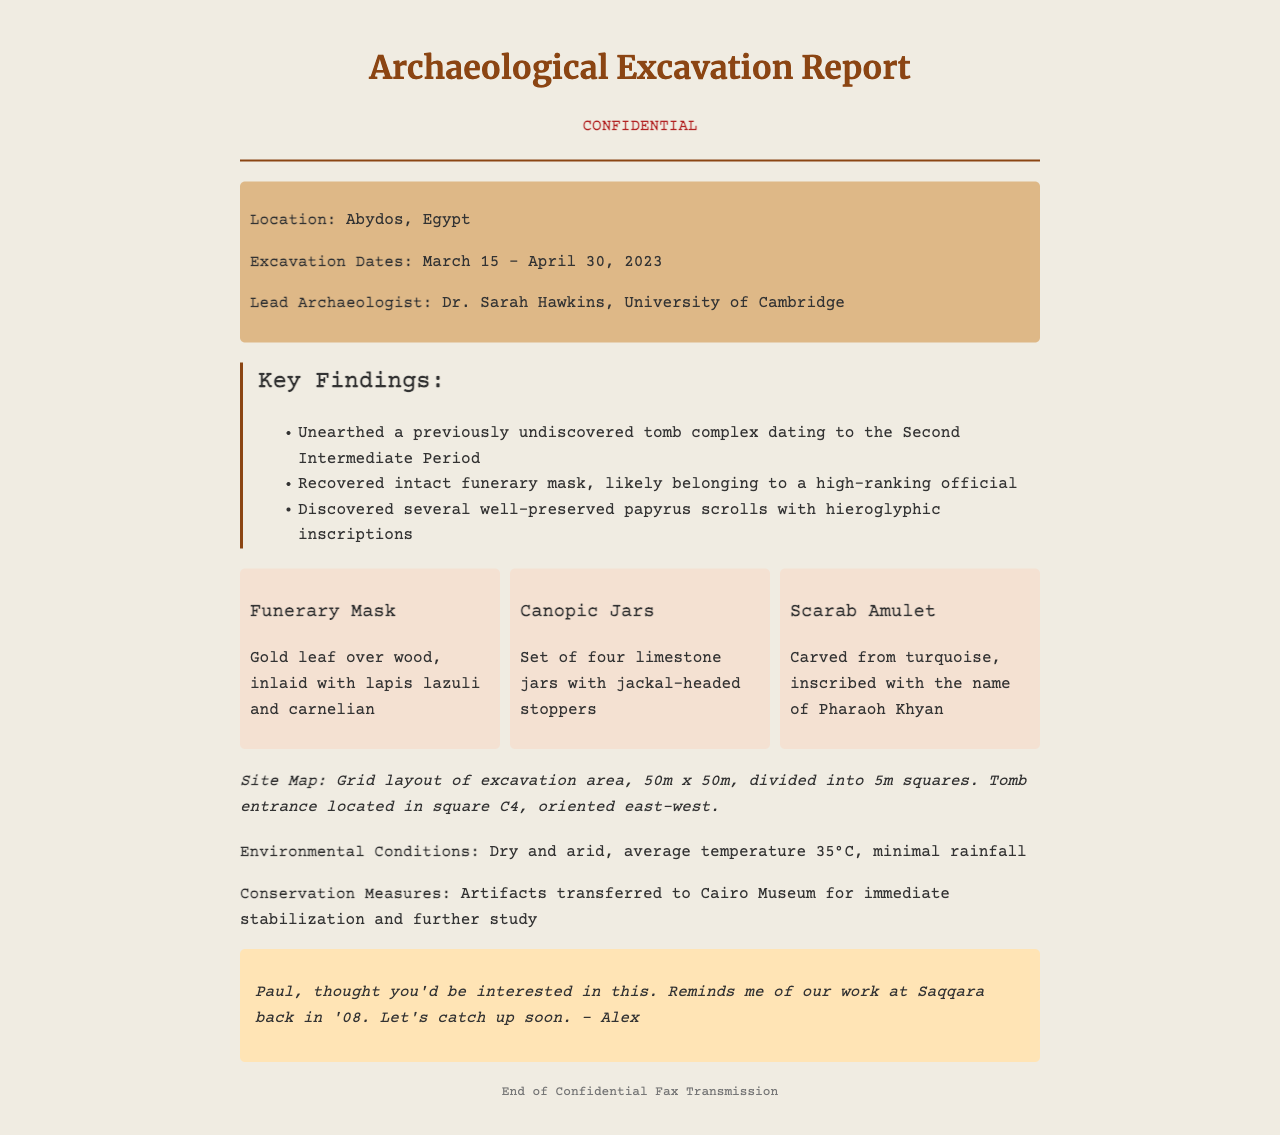What was the excavation location? The location of the excavation is provided in the document.
Answer: Abydos, Egypt Who was the lead archaeologist? The document mentions the lead archaeologist’s name along with their affiliation.
Answer: Dr. Sarah Hawkins, University of Cambridge What was unearthed during the excavation? The key findings section lists the important discoveries made at the site.
Answer: A previously undiscovered tomb complex What materials were used in the funerary mask? The artifacts section describes the composition of the funerary mask.
Answer: Gold leaf over wood, lapis lazuli, and carnelian What is the size of the excavation area? The site map information provides the dimensions of the excavation area.
Answer: 50m x 50m What orientation does the tomb entrance have? The site map information specifies the orientation of the tomb entrance.
Answer: East-west What were the environmental conditions like? The environmental conditions section describes the weather and temperature during the excavation.
Answer: Dry and arid, average temperature 35°C Where were the artifacts sent for conservation? The conservation measures section states where the artifacts were transferred for stabilization.
Answer: Cairo Museum What personal note did Alex include? The personal note gives insight into Alex's sentiment about the excavation and a reference to a shared past experience.
Answer: Reminds me of our work at Saqqara back in '08 